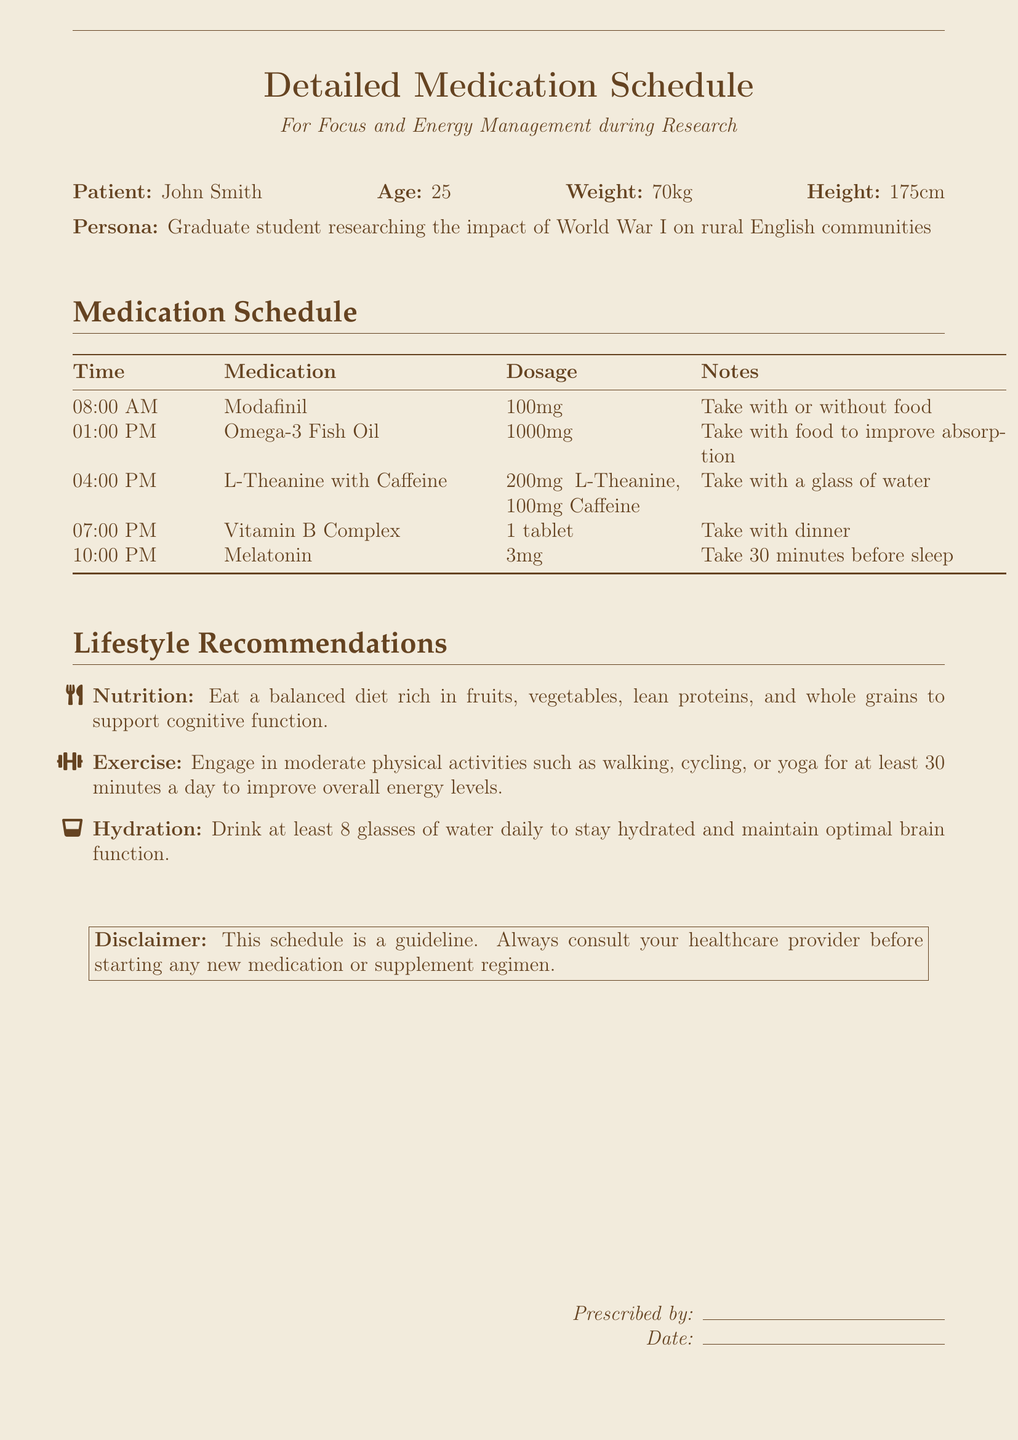What is the patient's name? The patient's name is listed at the top of the document.
Answer: John Smith What time should Modafinil be taken? The medication schedule specifies when each medication should be taken.
Answer: 08:00 AM What is the dosage for Omega-3 Fish Oil? The document indicates the dosage for Omega-3 Fish Oil in the medication table.
Answer: 1000mg How many milligrams of Caffeine are in the L-Theanine with Caffeine dosage? The dosage details for L-Theanine and Caffeine are provided in the same row of the medication schedule.
Answer: 100mg What is the recommended daily water intake? The lifestyle recommendations section provides hydration advice.
Answer: 8 glasses What is the purpose of taking Vitamin B Complex? The document does not specify, but it is implied to support overall energy levels.
Answer: Energy management What should be taken with food to improve absorption? This detail is included in the notes for a specific medication in the schedule.
Answer: Omega-3 Fish Oil How long before sleep should Melatonin be taken? The notes for Melatonin in the medication schedule indicate timing for its consumption.
Answer: 30 minutes Who prescribed the medication? The prescription section includes a line for the prescriber to sign.
Answer: Not specified 